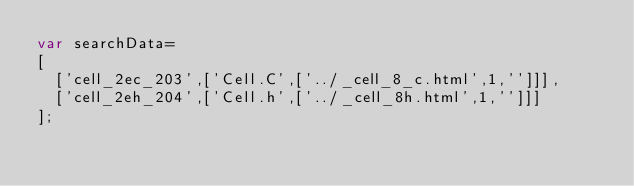<code> <loc_0><loc_0><loc_500><loc_500><_JavaScript_>var searchData=
[
  ['cell_2ec_203',['Cell.C',['../_cell_8_c.html',1,'']]],
  ['cell_2eh_204',['Cell.h',['../_cell_8h.html',1,'']]]
];
</code> 